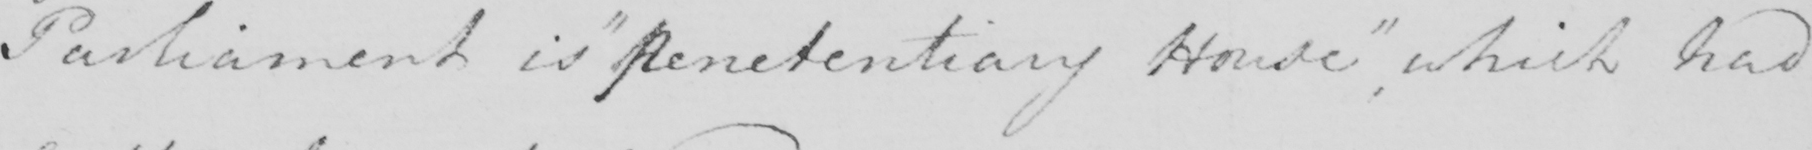What does this handwritten line say? Parliament is  " penitentiary House "  , which had 